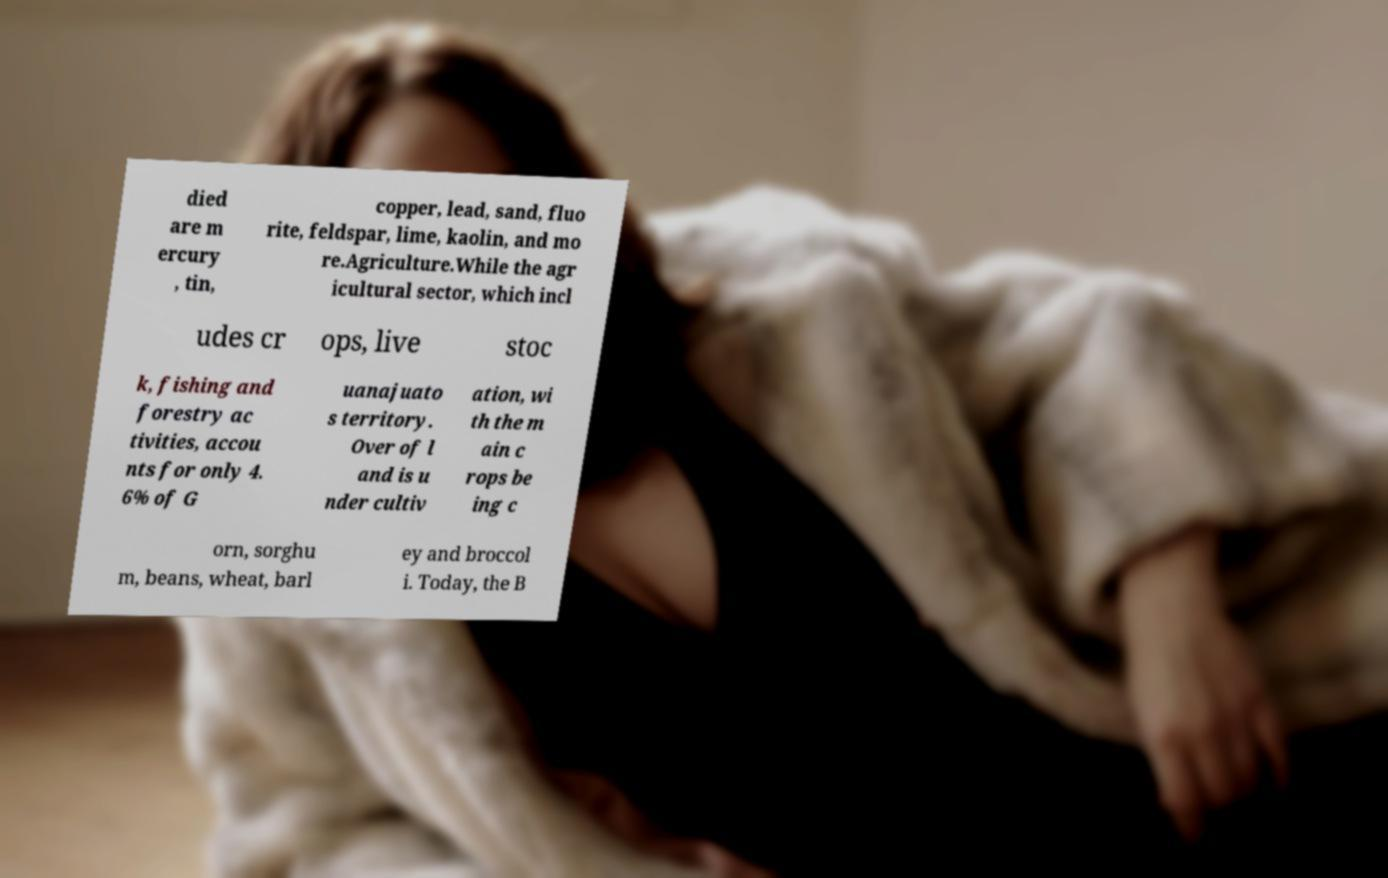Can you read and provide the text displayed in the image?This photo seems to have some interesting text. Can you extract and type it out for me? died are m ercury , tin, copper, lead, sand, fluo rite, feldspar, lime, kaolin, and mo re.Agriculture.While the agr icultural sector, which incl udes cr ops, live stoc k, fishing and forestry ac tivities, accou nts for only 4. 6% of G uanajuato s territory. Over of l and is u nder cultiv ation, wi th the m ain c rops be ing c orn, sorghu m, beans, wheat, barl ey and broccol i. Today, the B 